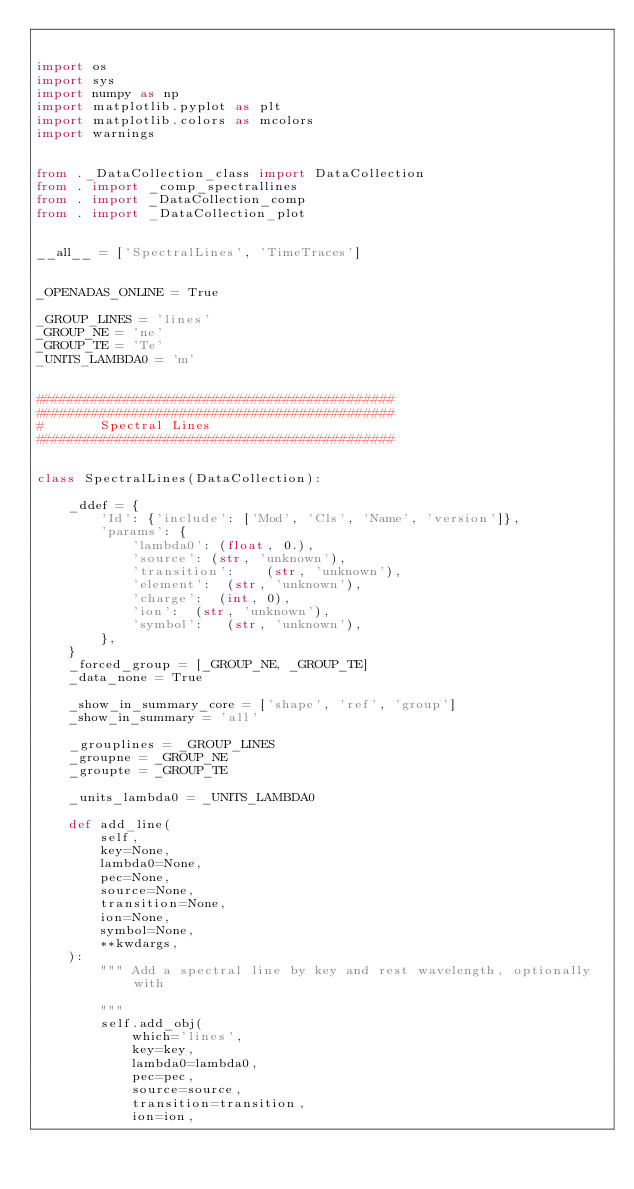Convert code to text. <code><loc_0><loc_0><loc_500><loc_500><_Python_>

import os
import sys
import numpy as np
import matplotlib.pyplot as plt
import matplotlib.colors as mcolors
import warnings


from ._DataCollection_class import DataCollection
from . import _comp_spectrallines
from . import _DataCollection_comp
from . import _DataCollection_plot


__all__ = ['SpectralLines', 'TimeTraces']


_OPENADAS_ONLINE = True

_GROUP_LINES = 'lines'
_GROUP_NE = 'ne'
_GROUP_TE = 'Te'
_UNITS_LAMBDA0 = 'm'


#############################################
#############################################
#       Spectral Lines
#############################################


class SpectralLines(DataCollection):

    _ddef = {
        'Id': {'include': ['Mod', 'Cls', 'Name', 'version']},
        'params': {
            'lambda0': (float, 0.),
            'source': (str, 'unknown'),
            'transition':    (str, 'unknown'),
            'element':  (str, 'unknown'),
            'charge':  (int, 0),
            'ion':  (str, 'unknown'),
            'symbol':   (str, 'unknown'),
        },
    }
    _forced_group = [_GROUP_NE, _GROUP_TE]
    _data_none = True

    _show_in_summary_core = ['shape', 'ref', 'group']
    _show_in_summary = 'all'

    _grouplines = _GROUP_LINES
    _groupne = _GROUP_NE
    _groupte = _GROUP_TE

    _units_lambda0 = _UNITS_LAMBDA0

    def add_line(
        self,
        key=None,
        lambda0=None,
        pec=None,
        source=None,
        transition=None,
        ion=None,
        symbol=None,
        **kwdargs,
    ):
        """ Add a spectral line by key and rest wavelength, optionally with

        """
        self.add_obj(
            which='lines',
            key=key,
            lambda0=lambda0,
            pec=pec,
            source=source,
            transition=transition,
            ion=ion,</code> 